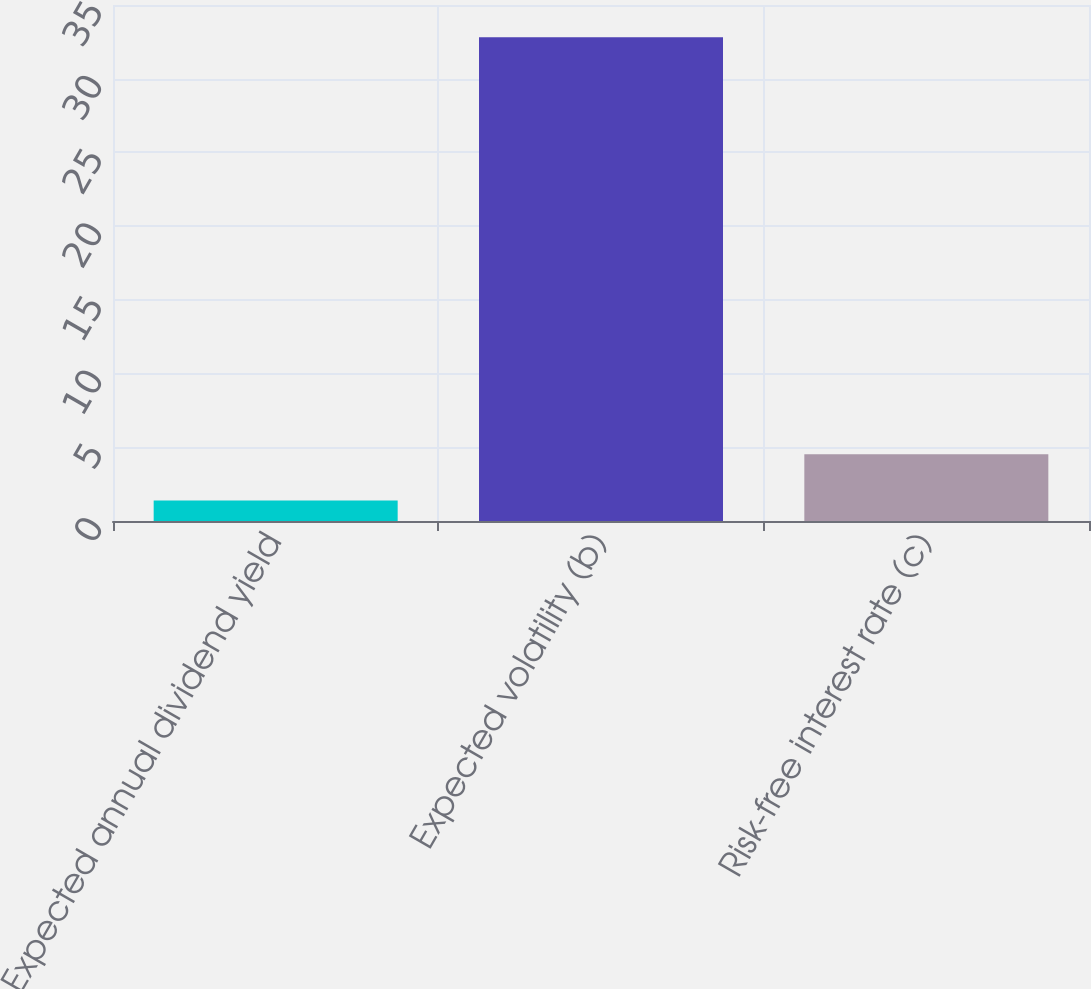Convert chart to OTSL. <chart><loc_0><loc_0><loc_500><loc_500><bar_chart><fcel>Expected annual dividend yield<fcel>Expected volatility (b)<fcel>Risk-free interest rate (c)<nl><fcel>1.39<fcel>32.82<fcel>4.53<nl></chart> 